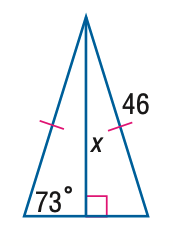Answer the mathemtical geometry problem and directly provide the correct option letter.
Question: Find x. Round to the nearest tenth.
Choices: A: 13.4 B: 31.1 C: 44.0 D: 46 C 